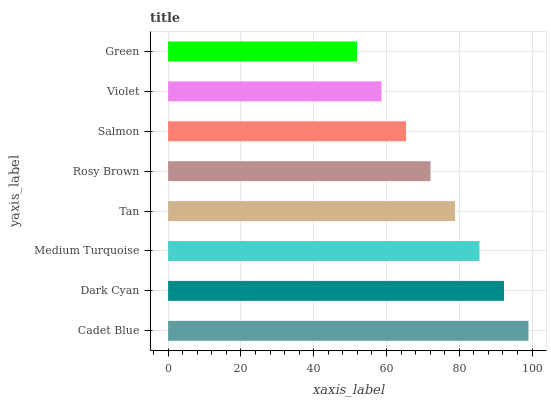Is Green the minimum?
Answer yes or no. Yes. Is Cadet Blue the maximum?
Answer yes or no. Yes. Is Dark Cyan the minimum?
Answer yes or no. No. Is Dark Cyan the maximum?
Answer yes or no. No. Is Cadet Blue greater than Dark Cyan?
Answer yes or no. Yes. Is Dark Cyan less than Cadet Blue?
Answer yes or no. Yes. Is Dark Cyan greater than Cadet Blue?
Answer yes or no. No. Is Cadet Blue less than Dark Cyan?
Answer yes or no. No. Is Tan the high median?
Answer yes or no. Yes. Is Rosy Brown the low median?
Answer yes or no. Yes. Is Salmon the high median?
Answer yes or no. No. Is Medium Turquoise the low median?
Answer yes or no. No. 